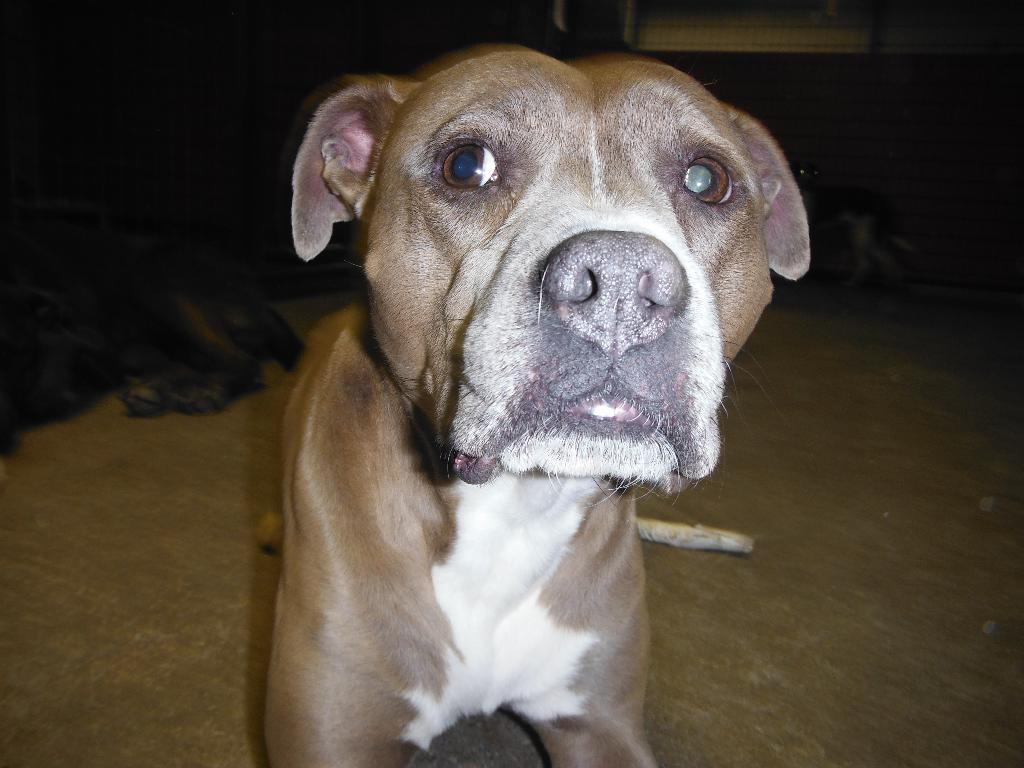What type of animal can be seen in the image? There is a dog in the image. Can you describe the background of the image? The background of the image is dark. Are there any other animals visible in the image? Yes, there is another dog in the background of the image. What type of jewel can be seen on the dog's collar in the image? There is no jewel visible on the dog's collar in the image. What design is featured on the volcano in the background of the image? There is no volcano present in the image; it features two dogs and a dark background. 